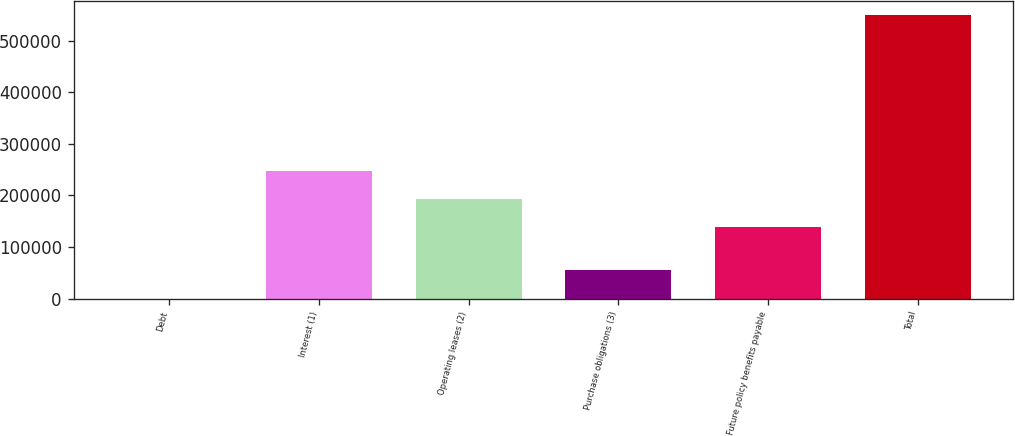Convert chart. <chart><loc_0><loc_0><loc_500><loc_500><bar_chart><fcel>Debt<fcel>Interest (1)<fcel>Operating leases (2)<fcel>Purchase obligations (3)<fcel>Future policy benefits payable<fcel>Total<nl><fcel>125<fcel>247976<fcel>193027<fcel>55074.2<fcel>138078<fcel>549617<nl></chart> 